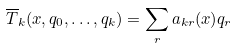Convert formula to latex. <formula><loc_0><loc_0><loc_500><loc_500>\overline { T } _ { k } ( x , q _ { 0 } , \dots , q _ { k } ) = \sum _ { r } a _ { k r } ( x ) q _ { r }</formula> 